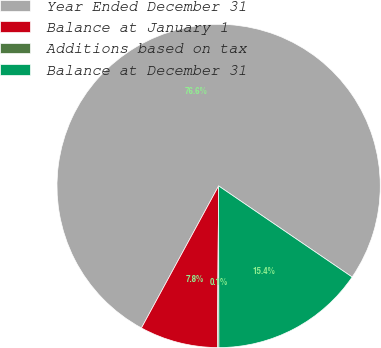Convert chart. <chart><loc_0><loc_0><loc_500><loc_500><pie_chart><fcel>Year Ended December 31<fcel>Balance at January 1<fcel>Additions based on tax<fcel>Balance at December 31<nl><fcel>76.61%<fcel>7.8%<fcel>0.15%<fcel>15.44%<nl></chart> 